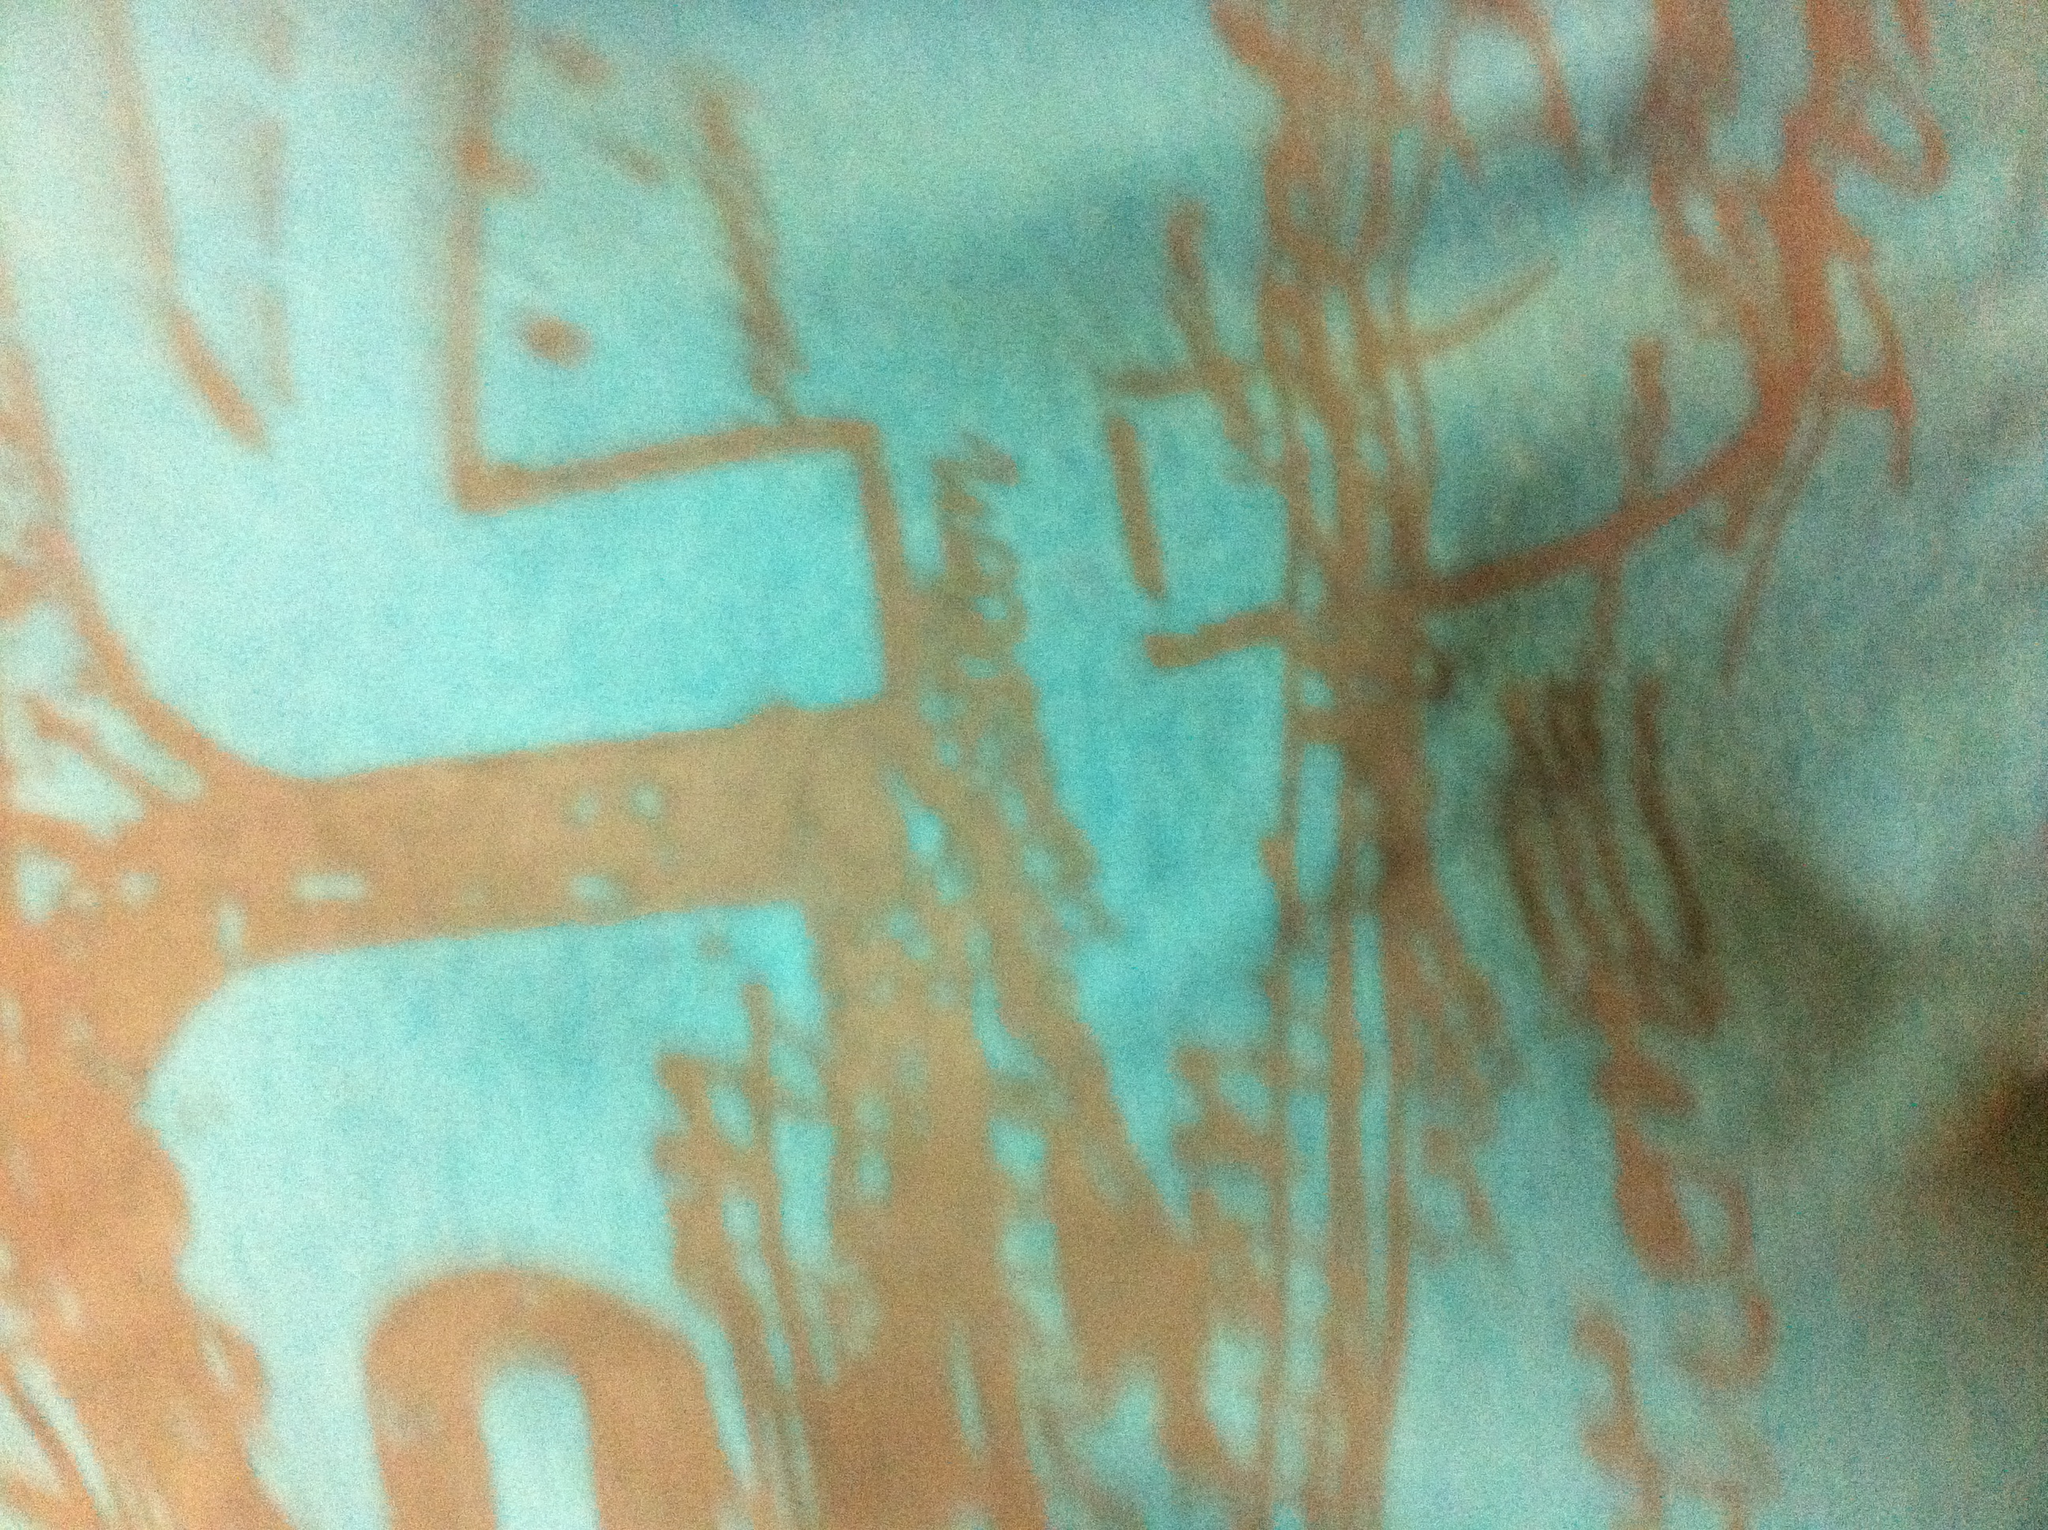If someone was wearing this shirt, what kind of accessories would complement it? Complementing this shirt with accessories like a pair of casual jeans or shorts in neutral colors would work well. Adding sunglasses, a simple necklace, or a woven bracelet would blend perfectly. For footwear, sandals or casual canvas shoes would complete the relaxed, stylish look. Describe an adventure where this shirt would be a perfect fit. Imagine embarking on a tropical beach adventure, where you spend the day exploring hidden coves, snorkeling in crystal-clear waters, and lounging on sun-drenched sands. The vibrant colors of the shirt mirror the lively marine life, and its comfortable fabric keeps you cool and stylish. As the day fades into a vivid sunset, the shirt becomes part of the perfect memory—a memory of carefree laughter, the embrace of the sea breeze, and the endless horizon where the sky meets the water. 